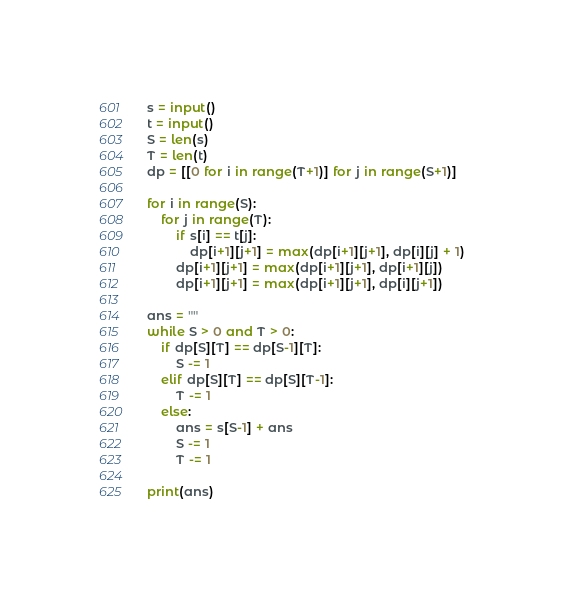<code> <loc_0><loc_0><loc_500><loc_500><_Python_>s = input()
t = input()
S = len(s)
T = len(t)
dp = [[0 for i in range(T+1)] for j in range(S+1)]

for i in range(S):
    for j in range(T):
        if s[i] == t[j]:
            dp[i+1][j+1] = max(dp[i+1][j+1], dp[i][j] + 1)
        dp[i+1][j+1] = max(dp[i+1][j+1], dp[i+1][j])
        dp[i+1][j+1] = max(dp[i+1][j+1], dp[i][j+1])

ans = ""
while S > 0 and T > 0:
    if dp[S][T] == dp[S-1][T]:
        S -= 1
    elif dp[S][T] == dp[S][T-1]:
        T -= 1
    else:
        ans = s[S-1] + ans
        S -= 1
        T -= 1

print(ans)</code> 